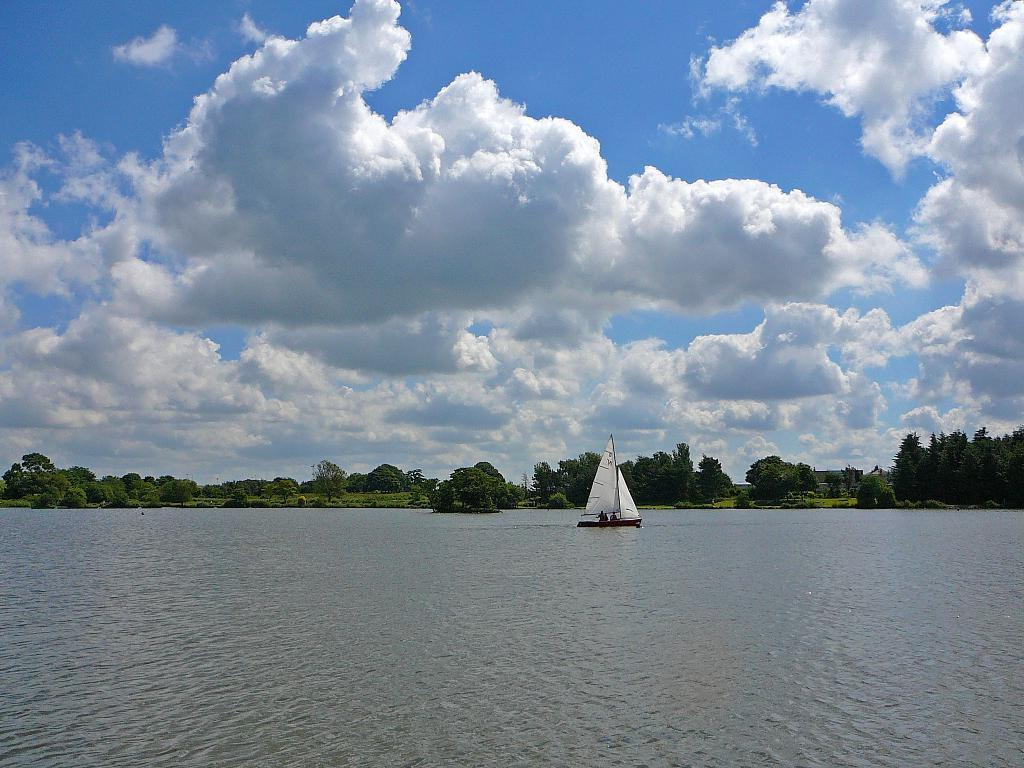What is the main subject of the image? The main subject of the image is a boat on a water surface. What is the boat doing in the image? The boat is on the water surface, and there are people sitting in it. What can be seen in the background of the image? There are many trees visible in the image, and the sky is also visible. What is the condition of the sky in the image? The sky is visible in the image, and clouds are present. How many cakes are being served on the boat in the image? There is no mention of cakes in the image; it features a boat on a water surface with people sitting in it. Is the boat stuck in quicksand in the image? There is no indication of quicksand in the image; the boat is on a water surface. 